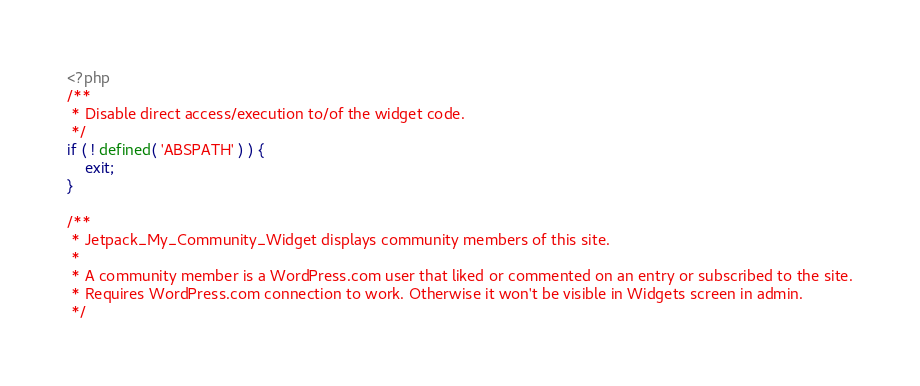<code> <loc_0><loc_0><loc_500><loc_500><_PHP_><?php
/**
 * Disable direct access/execution to/of the widget code.
 */
if ( ! defined( 'ABSPATH' ) ) {
	exit;
}

/**
 * Jetpack_My_Community_Widget displays community members of this site.
 *
 * A community member is a WordPress.com user that liked or commented on an entry or subscribed to the site.
 * Requires WordPress.com connection to work. Otherwise it won't be visible in Widgets screen in admin.
 */</code> 